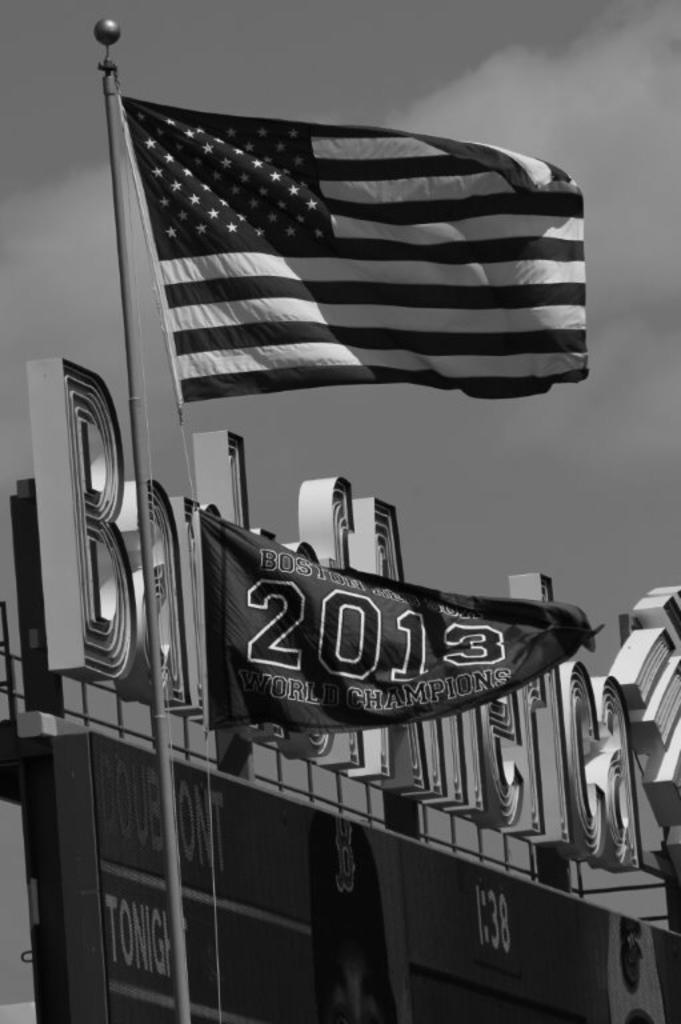<image>
Create a compact narrative representing the image presented. A flag flies above a banner commemorating Boston as the 2013 World Champions. 